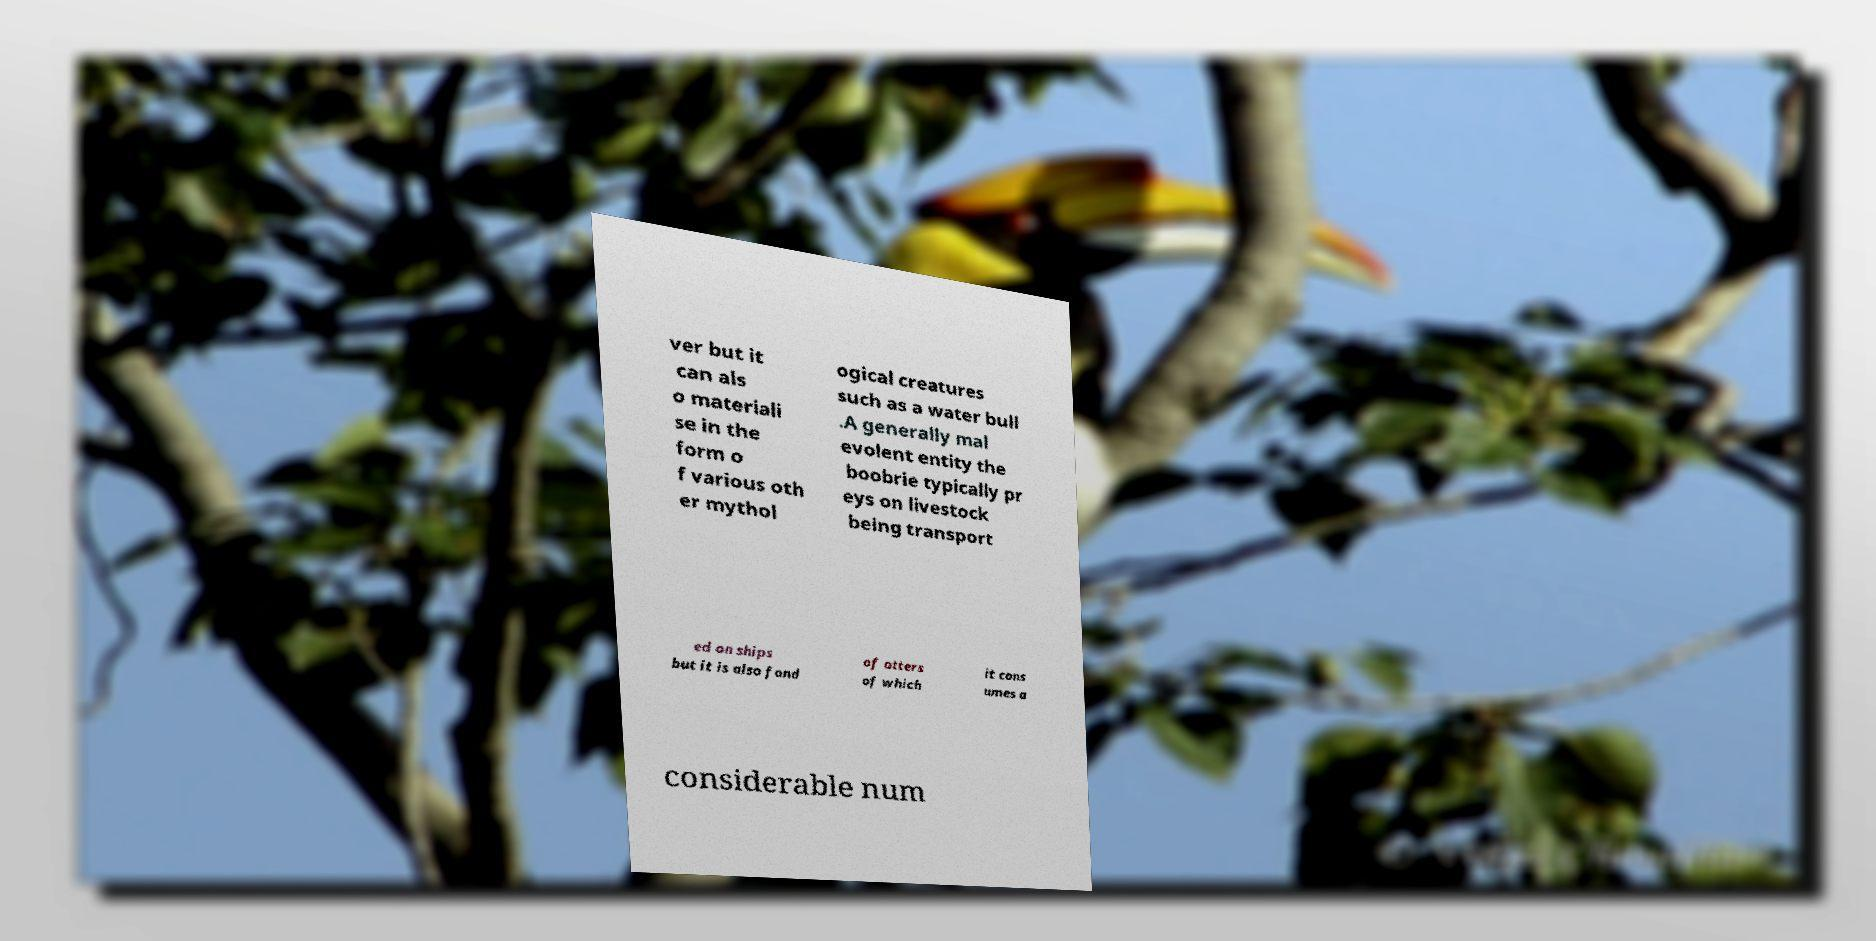Can you accurately transcribe the text from the provided image for me? ver but it can als o materiali se in the form o f various oth er mythol ogical creatures such as a water bull .A generally mal evolent entity the boobrie typically pr eys on livestock being transport ed on ships but it is also fond of otters of which it cons umes a considerable num 